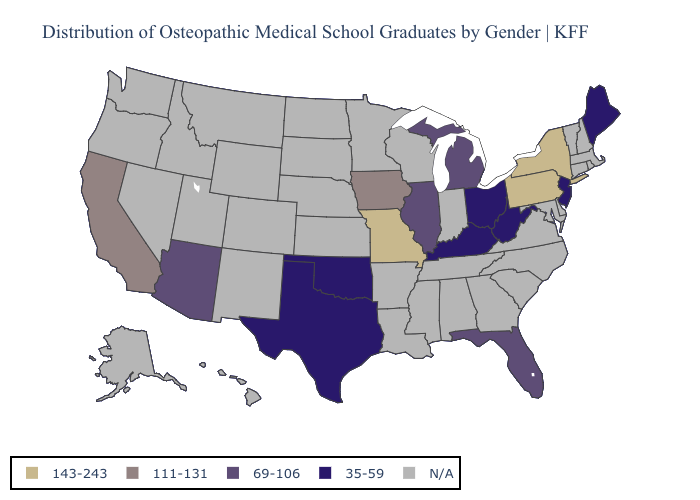What is the value of Kentucky?
Keep it brief. 35-59. Name the states that have a value in the range 143-243?
Be succinct. Missouri, New York, Pennsylvania. Does Pennsylvania have the highest value in the USA?
Write a very short answer. Yes. Name the states that have a value in the range N/A?
Quick response, please. Alabama, Alaska, Arkansas, Colorado, Connecticut, Delaware, Georgia, Hawaii, Idaho, Indiana, Kansas, Louisiana, Maryland, Massachusetts, Minnesota, Mississippi, Montana, Nebraska, Nevada, New Hampshire, New Mexico, North Carolina, North Dakota, Oregon, Rhode Island, South Carolina, South Dakota, Tennessee, Utah, Vermont, Virginia, Washington, Wisconsin, Wyoming. Does the map have missing data?
Keep it brief. Yes. Name the states that have a value in the range 111-131?
Short answer required. California, Iowa. What is the value of Washington?
Keep it brief. N/A. What is the value of Rhode Island?
Write a very short answer. N/A. Is the legend a continuous bar?
Write a very short answer. No. What is the highest value in the West ?
Quick response, please. 111-131. Name the states that have a value in the range N/A?
Quick response, please. Alabama, Alaska, Arkansas, Colorado, Connecticut, Delaware, Georgia, Hawaii, Idaho, Indiana, Kansas, Louisiana, Maryland, Massachusetts, Minnesota, Mississippi, Montana, Nebraska, Nevada, New Hampshire, New Mexico, North Carolina, North Dakota, Oregon, Rhode Island, South Carolina, South Dakota, Tennessee, Utah, Vermont, Virginia, Washington, Wisconsin, Wyoming. What is the highest value in states that border Texas?
Answer briefly. 35-59. What is the value of Utah?
Quick response, please. N/A. Name the states that have a value in the range 143-243?
Write a very short answer. Missouri, New York, Pennsylvania. 